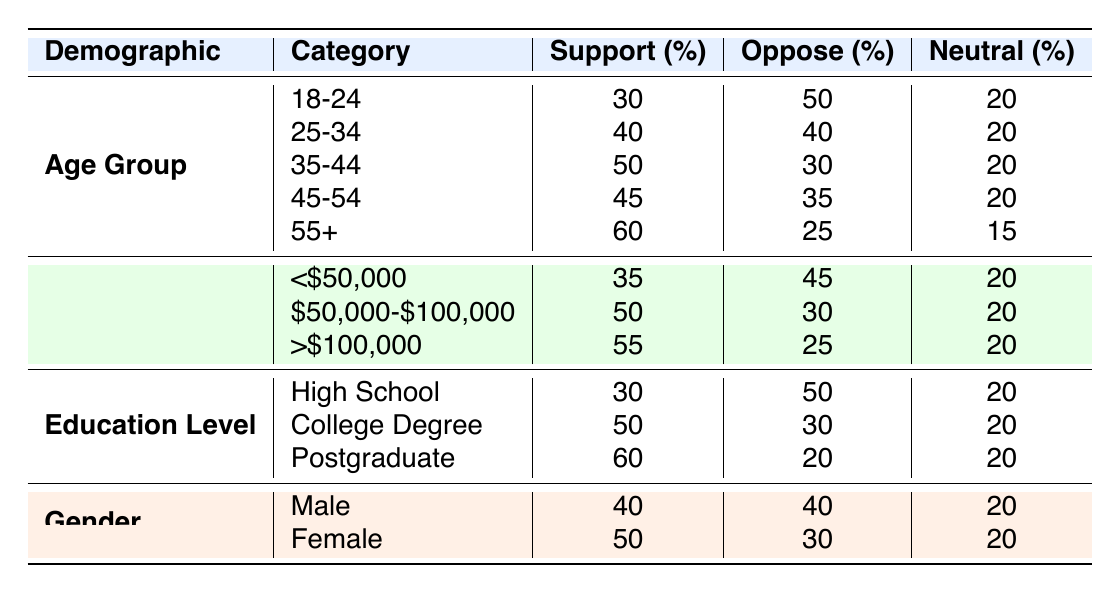What percentage of individuals aged 55 and over support disarmament policies? In the table, for the age group 55+, the support percentage is directly listed as 60.
Answer: 60 What is the opposition percentage for people with a college degree? The table shows that for individuals with a college degree, the opposition percentage is 30.
Answer: 30 For which income level is support for disarmament policies the highest? Comparing the support percentages for each income level, we see that >$100,000 has the highest support at 55.
Answer: >$100,000 What is the difference in support between the age groups 18-24 and 35-44? From the table, 18-24 has a support of 30 and 35-44 has a support of 50. The difference is 50 - 30 = 20.
Answer: 20 Is it true that females show more support for disarmament policies than males? The support percentage for females is 50, while for males it is 40. Therefore, the statement is true.
Answer: Yes What is the average support percentage for the age groups listed? The support percentages for the age groups are 30, 40, 50, 45, and 60. Adding these gives 225, and dividing by 5 provides an average of 45.
Answer: 45 Which demographic category has the highest percentage of opposition overall? To determine this, we look at the highest opposition values across demographics: 50 (age group 18-24), 50 (education level high school), and 45 (income level <$50,000). The highest opposition is 50 for both age group 18-24 and education level high school.
Answer: Age group 18-24 and education level high school How many demographic categories show an overall majority in support for disarmament policies? Analyzing the table, we see that 3 categories (age 35-44, income >$100,000, and education postgraduate) have a majority of support, as they have more than 50% in support. Thus, there are 3 categories.
Answer: 3 What is the neutral percentage for individuals aged 45-54? Referring to the table, the neutral percentage for the age group 45-54 is 20.
Answer: 20 Is support for disarmament policies consistently increasing with age? Looking at the age groups, support increases from 30 (18-24) to 60 (55+), thus the conclusion is yes, support is consistently increasing with age.
Answer: Yes 